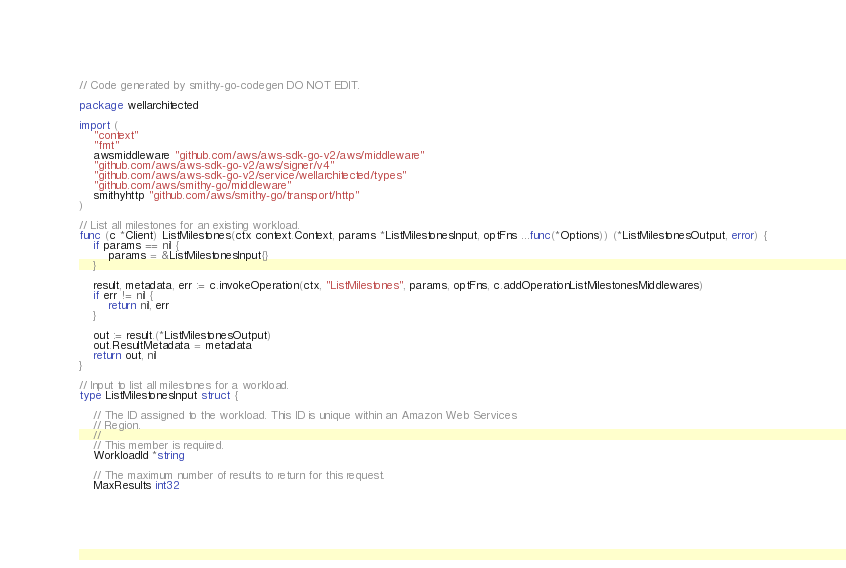<code> <loc_0><loc_0><loc_500><loc_500><_Go_>// Code generated by smithy-go-codegen DO NOT EDIT.

package wellarchitected

import (
	"context"
	"fmt"
	awsmiddleware "github.com/aws/aws-sdk-go-v2/aws/middleware"
	"github.com/aws/aws-sdk-go-v2/aws/signer/v4"
	"github.com/aws/aws-sdk-go-v2/service/wellarchitected/types"
	"github.com/aws/smithy-go/middleware"
	smithyhttp "github.com/aws/smithy-go/transport/http"
)

// List all milestones for an existing workload.
func (c *Client) ListMilestones(ctx context.Context, params *ListMilestonesInput, optFns ...func(*Options)) (*ListMilestonesOutput, error) {
	if params == nil {
		params = &ListMilestonesInput{}
	}

	result, metadata, err := c.invokeOperation(ctx, "ListMilestones", params, optFns, c.addOperationListMilestonesMiddlewares)
	if err != nil {
		return nil, err
	}

	out := result.(*ListMilestonesOutput)
	out.ResultMetadata = metadata
	return out, nil
}

// Input to list all milestones for a workload.
type ListMilestonesInput struct {

	// The ID assigned to the workload. This ID is unique within an Amazon Web Services
	// Region.
	//
	// This member is required.
	WorkloadId *string

	// The maximum number of results to return for this request.
	MaxResults int32
</code> 